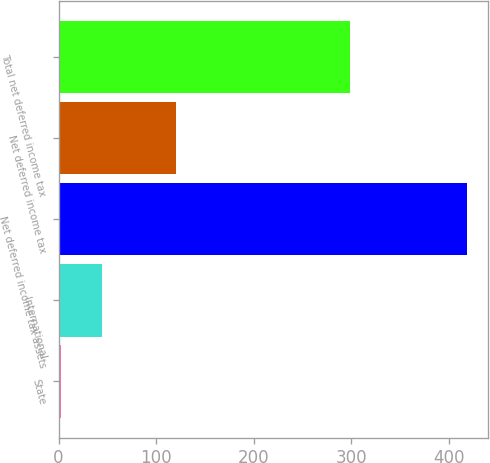Convert chart. <chart><loc_0><loc_0><loc_500><loc_500><bar_chart><fcel>State<fcel>International<fcel>Net deferred income tax assets<fcel>Net deferred income tax<fcel>Total net deferred income tax<nl><fcel>2.6<fcel>44.23<fcel>418.9<fcel>120.2<fcel>298.7<nl></chart> 